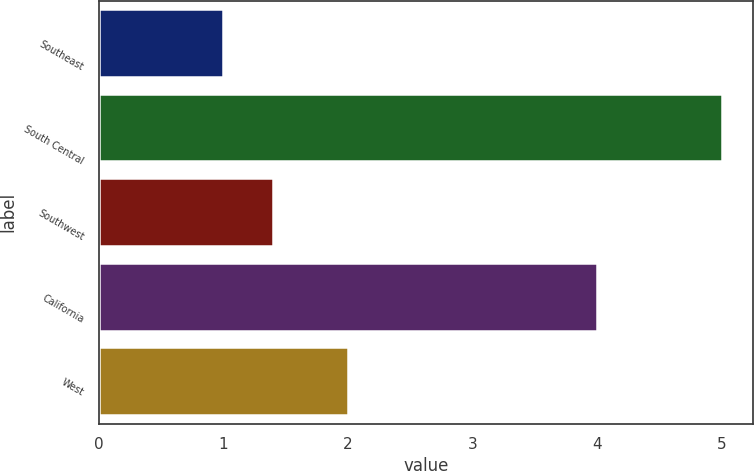<chart> <loc_0><loc_0><loc_500><loc_500><bar_chart><fcel>Southeast<fcel>South Central<fcel>Southwest<fcel>California<fcel>West<nl><fcel>1<fcel>5<fcel>1.4<fcel>4<fcel>2<nl></chart> 